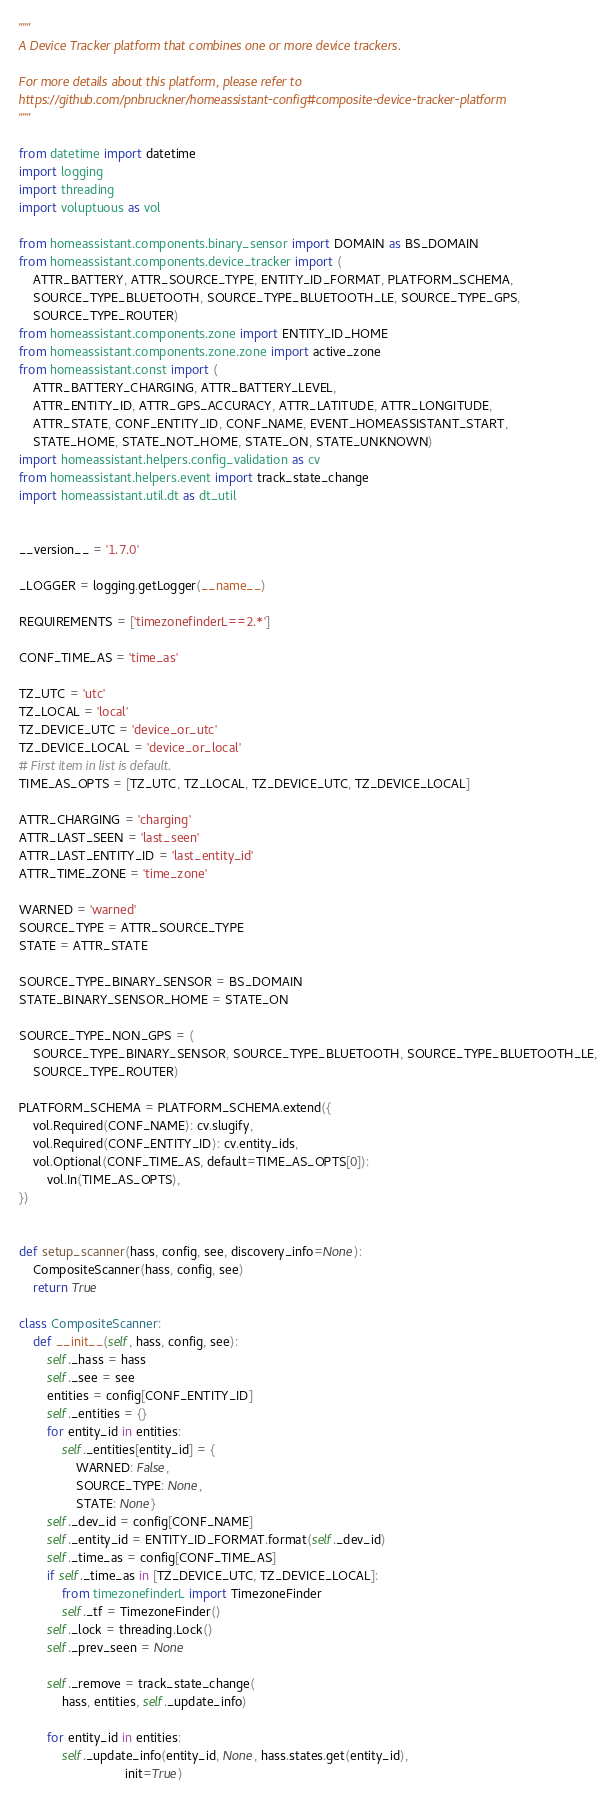Convert code to text. <code><loc_0><loc_0><loc_500><loc_500><_Python_>"""
A Device Tracker platform that combines one or more device trackers.

For more details about this platform, please refer to
https://github.com/pnbruckner/homeassistant-config#composite-device-tracker-platform
"""

from datetime import datetime
import logging
import threading
import voluptuous as vol

from homeassistant.components.binary_sensor import DOMAIN as BS_DOMAIN
from homeassistant.components.device_tracker import (
    ATTR_BATTERY, ATTR_SOURCE_TYPE, ENTITY_ID_FORMAT, PLATFORM_SCHEMA,
    SOURCE_TYPE_BLUETOOTH, SOURCE_TYPE_BLUETOOTH_LE, SOURCE_TYPE_GPS,
    SOURCE_TYPE_ROUTER)
from homeassistant.components.zone import ENTITY_ID_HOME
from homeassistant.components.zone.zone import active_zone
from homeassistant.const import (
    ATTR_BATTERY_CHARGING, ATTR_BATTERY_LEVEL,
    ATTR_ENTITY_ID, ATTR_GPS_ACCURACY, ATTR_LATITUDE, ATTR_LONGITUDE,
    ATTR_STATE, CONF_ENTITY_ID, CONF_NAME, EVENT_HOMEASSISTANT_START,
    STATE_HOME, STATE_NOT_HOME, STATE_ON, STATE_UNKNOWN)
import homeassistant.helpers.config_validation as cv
from homeassistant.helpers.event import track_state_change
import homeassistant.util.dt as dt_util


__version__ = '1.7.0'

_LOGGER = logging.getLogger(__name__)

REQUIREMENTS = ['timezonefinderL==2.*']

CONF_TIME_AS = 'time_as'

TZ_UTC = 'utc'
TZ_LOCAL = 'local'
TZ_DEVICE_UTC = 'device_or_utc'
TZ_DEVICE_LOCAL = 'device_or_local'
# First item in list is default.
TIME_AS_OPTS = [TZ_UTC, TZ_LOCAL, TZ_DEVICE_UTC, TZ_DEVICE_LOCAL]

ATTR_CHARGING = 'charging'
ATTR_LAST_SEEN = 'last_seen'
ATTR_LAST_ENTITY_ID = 'last_entity_id'
ATTR_TIME_ZONE = 'time_zone'

WARNED = 'warned'
SOURCE_TYPE = ATTR_SOURCE_TYPE
STATE = ATTR_STATE

SOURCE_TYPE_BINARY_SENSOR = BS_DOMAIN
STATE_BINARY_SENSOR_HOME = STATE_ON

SOURCE_TYPE_NON_GPS = (
    SOURCE_TYPE_BINARY_SENSOR, SOURCE_TYPE_BLUETOOTH, SOURCE_TYPE_BLUETOOTH_LE,
    SOURCE_TYPE_ROUTER)

PLATFORM_SCHEMA = PLATFORM_SCHEMA.extend({
    vol.Required(CONF_NAME): cv.slugify,
    vol.Required(CONF_ENTITY_ID): cv.entity_ids,
    vol.Optional(CONF_TIME_AS, default=TIME_AS_OPTS[0]):
        vol.In(TIME_AS_OPTS),
})


def setup_scanner(hass, config, see, discovery_info=None):
    CompositeScanner(hass, config, see)
    return True

class CompositeScanner:
    def __init__(self, hass, config, see):
        self._hass = hass
        self._see = see
        entities = config[CONF_ENTITY_ID]
        self._entities = {}
        for entity_id in entities:
            self._entities[entity_id] = {
                WARNED: False,
                SOURCE_TYPE: None,
                STATE: None}
        self._dev_id = config[CONF_NAME]
        self._entity_id = ENTITY_ID_FORMAT.format(self._dev_id)
        self._time_as = config[CONF_TIME_AS]
        if self._time_as in [TZ_DEVICE_UTC, TZ_DEVICE_LOCAL]:
            from timezonefinderL import TimezoneFinder
            self._tf = TimezoneFinder()
        self._lock = threading.Lock()
        self._prev_seen = None

        self._remove = track_state_change(
            hass, entities, self._update_info)

        for entity_id in entities:
            self._update_info(entity_id, None, hass.states.get(entity_id),
                              init=True)
</code> 